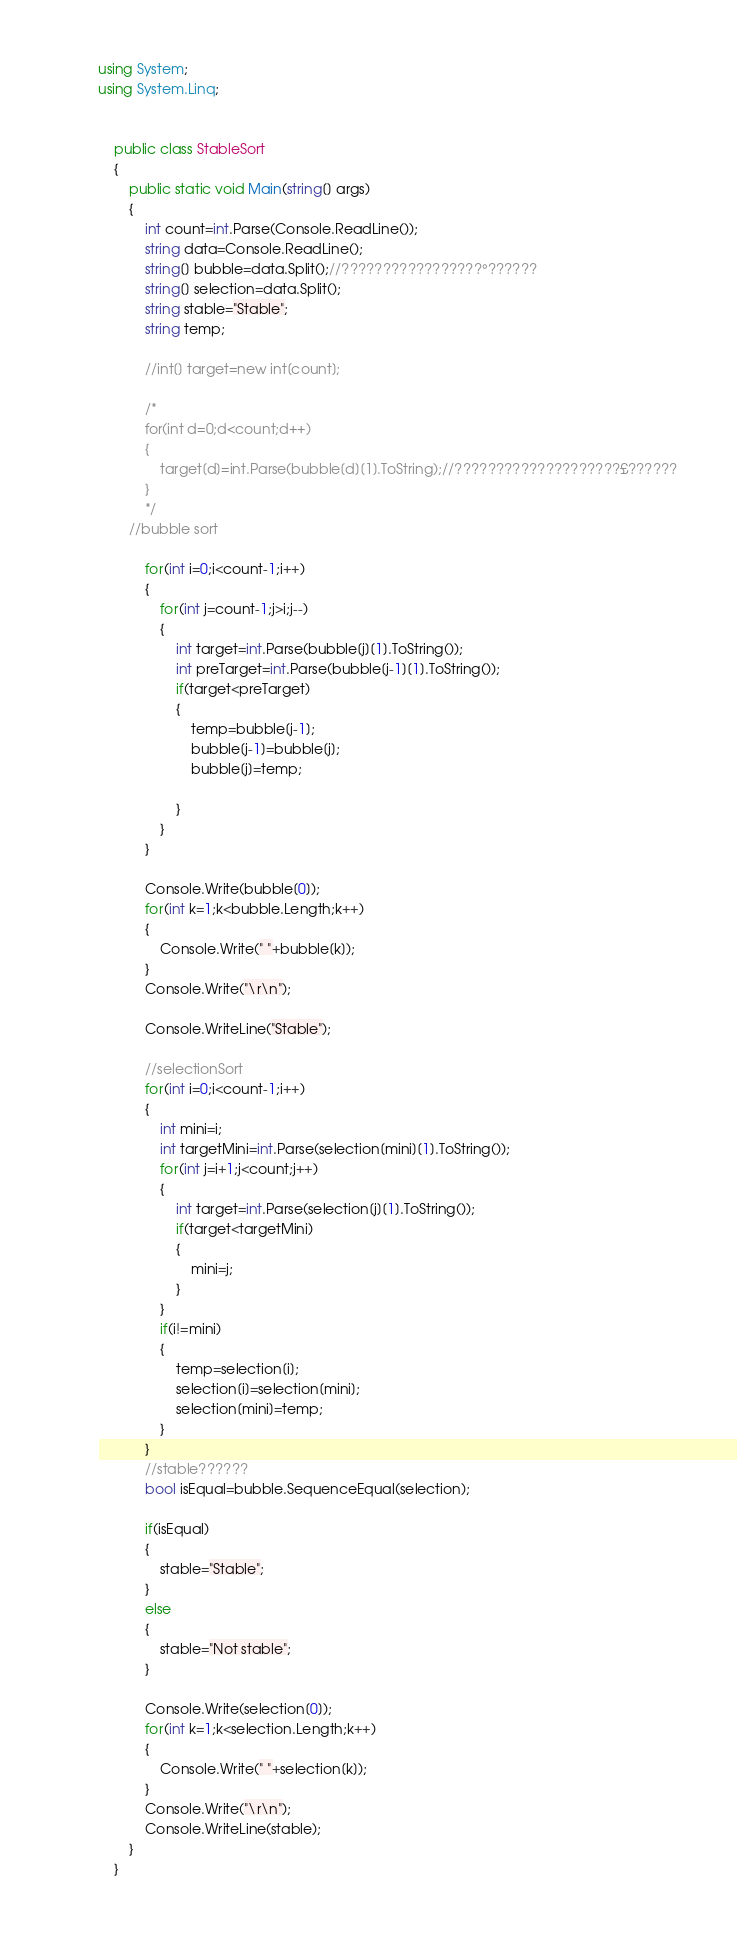Convert code to text. <code><loc_0><loc_0><loc_500><loc_500><_C#_>
using System;
using System.Linq;


	public class StableSort
	{
		public static void Main(string[] args)
		{
			int count=int.Parse(Console.ReadLine());			
			string data=Console.ReadLine();
			string[] bubble=data.Split();//?????????????????°??????
			string[] selection=data.Split();
			string stable="Stable";
			string temp;
		
			//int[] target=new int[count];
			
			/*
			for(int d=0;d<count;d++)
			{
				target[d]=int.Parse(bubble[d][1].ToString);//????????????????????£??????
			}
			*/
		//bubble sort

			for(int i=0;i<count-1;i++)
			{
				for(int j=count-1;j>i;j--)
				{
					int target=int.Parse(bubble[j][1].ToString());
					int preTarget=int.Parse(bubble[j-1][1].ToString());
					if(target<preTarget)
					{
						temp=bubble[j-1];
						bubble[j-1]=bubble[j];
						bubble[j]=temp;
						
					}
				}				
			}
			
			Console.Write(bubble[0]);
			for(int k=1;k<bubble.Length;k++)
			{
				Console.Write(" "+bubble[k]);
			}
			Console.Write("\r\n");
			
			Console.WriteLine("Stable");
			
			//selectionSort
			for(int i=0;i<count-1;i++)
			{  
				int mini=i;
				int targetMini=int.Parse(selection[mini][1].ToString());
				for(int j=i+1;j<count;j++)
				{
					int target=int.Parse(selection[j][1].ToString());
					if(target<targetMini)
					{
						mini=j;						
					}					
				}
				if(i!=mini)
				{
					temp=selection[i];
					selection[i]=selection[mini];
					selection[mini]=temp;
				}
			}
			//stable??????
			bool isEqual=bubble.SequenceEqual(selection);
			
			if(isEqual)
			{
				stable="Stable";
			}
			else
			{
				stable="Not stable";
			}
			
			Console.Write(selection[0]);
			for(int k=1;k<selection.Length;k++)
			{
				Console.Write(" "+selection[k]);
			}
			Console.Write("\r\n");
			Console.WriteLine(stable);
		}
	}</code> 